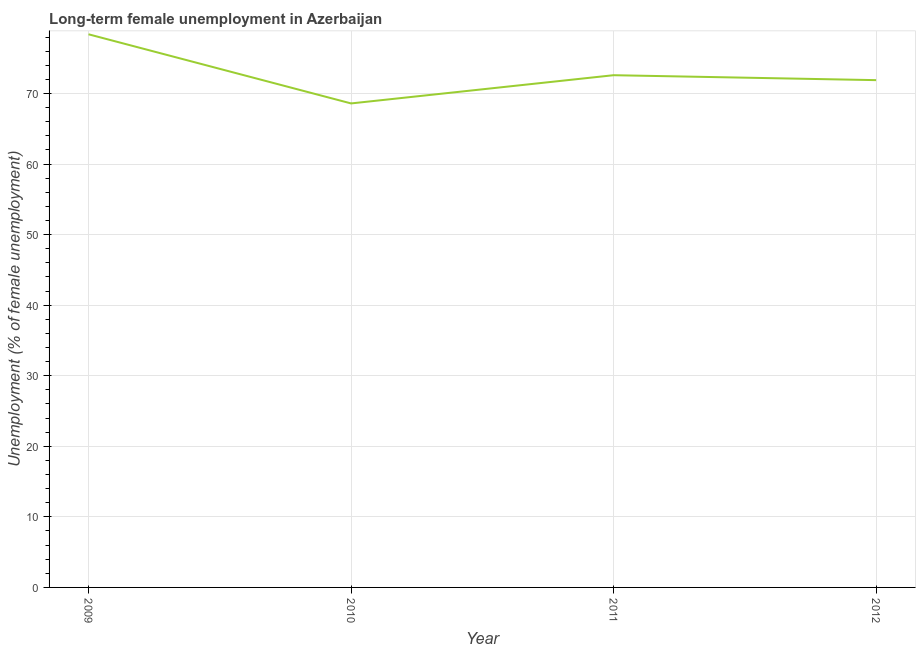What is the long-term female unemployment in 2012?
Your answer should be very brief. 71.9. Across all years, what is the maximum long-term female unemployment?
Your response must be concise. 78.4. Across all years, what is the minimum long-term female unemployment?
Offer a very short reply. 68.6. In which year was the long-term female unemployment minimum?
Provide a short and direct response. 2010. What is the sum of the long-term female unemployment?
Provide a short and direct response. 291.5. What is the difference between the long-term female unemployment in 2010 and 2012?
Provide a short and direct response. -3.3. What is the average long-term female unemployment per year?
Offer a terse response. 72.87. What is the median long-term female unemployment?
Keep it short and to the point. 72.25. What is the ratio of the long-term female unemployment in 2009 to that in 2012?
Offer a terse response. 1.09. Is the difference between the long-term female unemployment in 2009 and 2012 greater than the difference between any two years?
Ensure brevity in your answer.  No. What is the difference between the highest and the second highest long-term female unemployment?
Offer a terse response. 5.8. Is the sum of the long-term female unemployment in 2010 and 2011 greater than the maximum long-term female unemployment across all years?
Your response must be concise. Yes. What is the difference between the highest and the lowest long-term female unemployment?
Make the answer very short. 9.8. In how many years, is the long-term female unemployment greater than the average long-term female unemployment taken over all years?
Provide a succinct answer. 1. Does the long-term female unemployment monotonically increase over the years?
Offer a terse response. No. How many years are there in the graph?
Give a very brief answer. 4. What is the difference between two consecutive major ticks on the Y-axis?
Keep it short and to the point. 10. Are the values on the major ticks of Y-axis written in scientific E-notation?
Your response must be concise. No. Does the graph contain any zero values?
Provide a succinct answer. No. What is the title of the graph?
Your answer should be compact. Long-term female unemployment in Azerbaijan. What is the label or title of the Y-axis?
Provide a succinct answer. Unemployment (% of female unemployment). What is the Unemployment (% of female unemployment) in 2009?
Your response must be concise. 78.4. What is the Unemployment (% of female unemployment) of 2010?
Keep it short and to the point. 68.6. What is the Unemployment (% of female unemployment) in 2011?
Make the answer very short. 72.6. What is the Unemployment (% of female unemployment) of 2012?
Ensure brevity in your answer.  71.9. What is the difference between the Unemployment (% of female unemployment) in 2009 and 2010?
Offer a very short reply. 9.8. What is the difference between the Unemployment (% of female unemployment) in 2009 and 2012?
Ensure brevity in your answer.  6.5. What is the difference between the Unemployment (% of female unemployment) in 2010 and 2012?
Offer a terse response. -3.3. What is the ratio of the Unemployment (% of female unemployment) in 2009 to that in 2010?
Keep it short and to the point. 1.14. What is the ratio of the Unemployment (% of female unemployment) in 2009 to that in 2011?
Provide a succinct answer. 1.08. What is the ratio of the Unemployment (% of female unemployment) in 2009 to that in 2012?
Your answer should be compact. 1.09. What is the ratio of the Unemployment (% of female unemployment) in 2010 to that in 2011?
Provide a succinct answer. 0.94. What is the ratio of the Unemployment (% of female unemployment) in 2010 to that in 2012?
Keep it short and to the point. 0.95. What is the ratio of the Unemployment (% of female unemployment) in 2011 to that in 2012?
Ensure brevity in your answer.  1.01. 